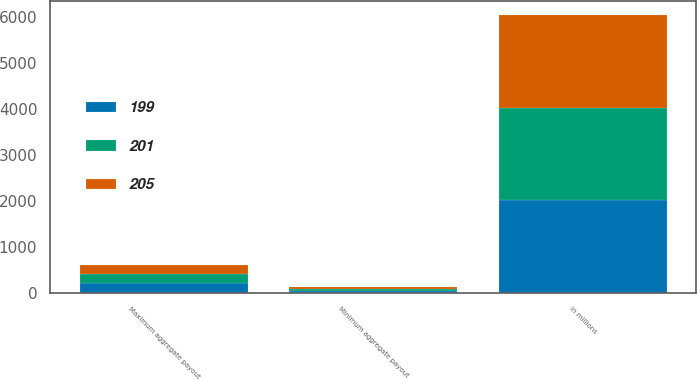Convert chart. <chart><loc_0><loc_0><loc_500><loc_500><stacked_bar_chart><ecel><fcel>in millions<fcel>Minimum aggregate payout<fcel>Maximum aggregate payout<nl><fcel>205<fcel>2018<fcel>36<fcel>205<nl><fcel>201<fcel>2017<fcel>38<fcel>201<nl><fcel>199<fcel>2016<fcel>39<fcel>199<nl></chart> 